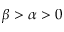Convert formula to latex. <formula><loc_0><loc_0><loc_500><loc_500>\beta > \alpha > 0</formula> 